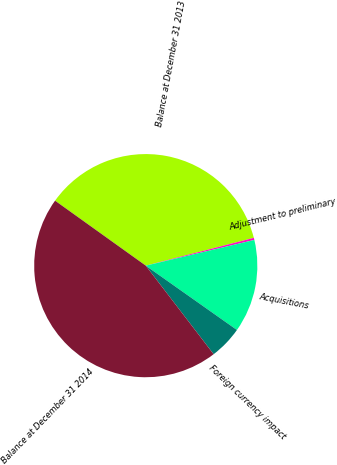Convert chart to OTSL. <chart><loc_0><loc_0><loc_500><loc_500><pie_chart><fcel>Balance at December 31 2013<fcel>Adjustment to preliminary<fcel>Acquisitions<fcel>Foreign currency impact<fcel>Balance at December 31 2014<nl><fcel>36.1%<fcel>0.31%<fcel>13.48%<fcel>4.81%<fcel>45.3%<nl></chart> 